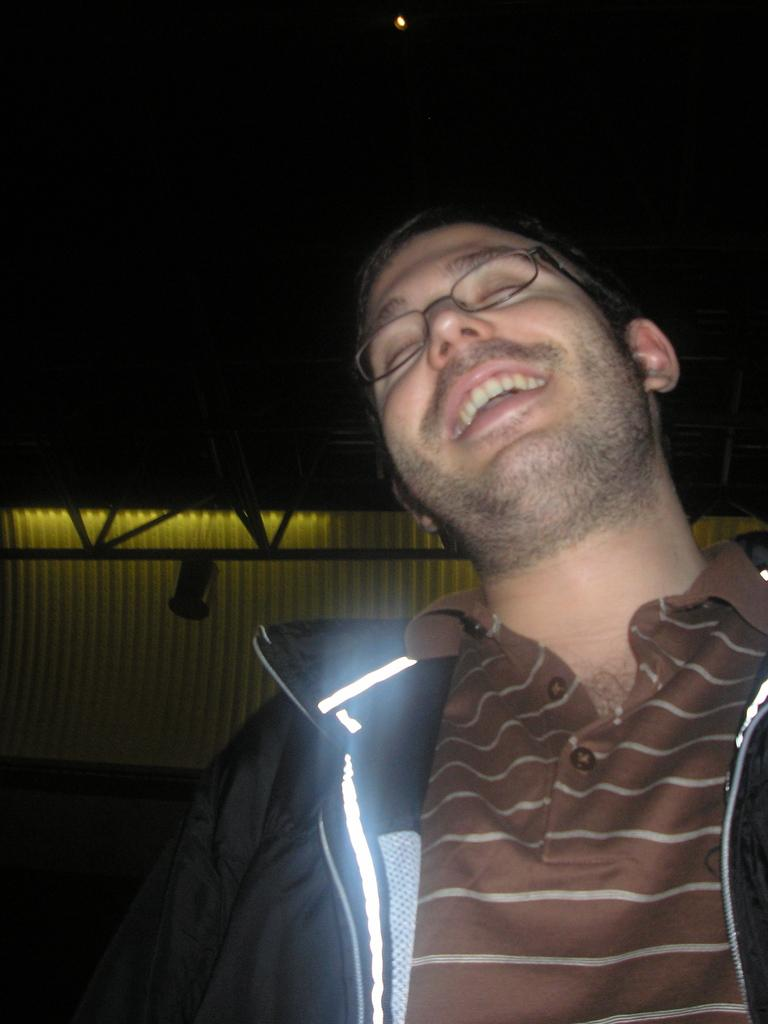What is the main subject in the foreground of the image? There is a person in the foreground of the image. Can you describe the person's appearance? The person is wearing spectacles. What can be seen in the background of the image? There are poles and lights in the background of the image. How would you describe the lighting conditions in the image? The top of the image appears to be dark. What type of lunch is the person eating in the image? There is no indication of the person eating lunch in the image. Can you describe the ornament hanging from the poles in the background? There is no ornament hanging from the poles in the image. 